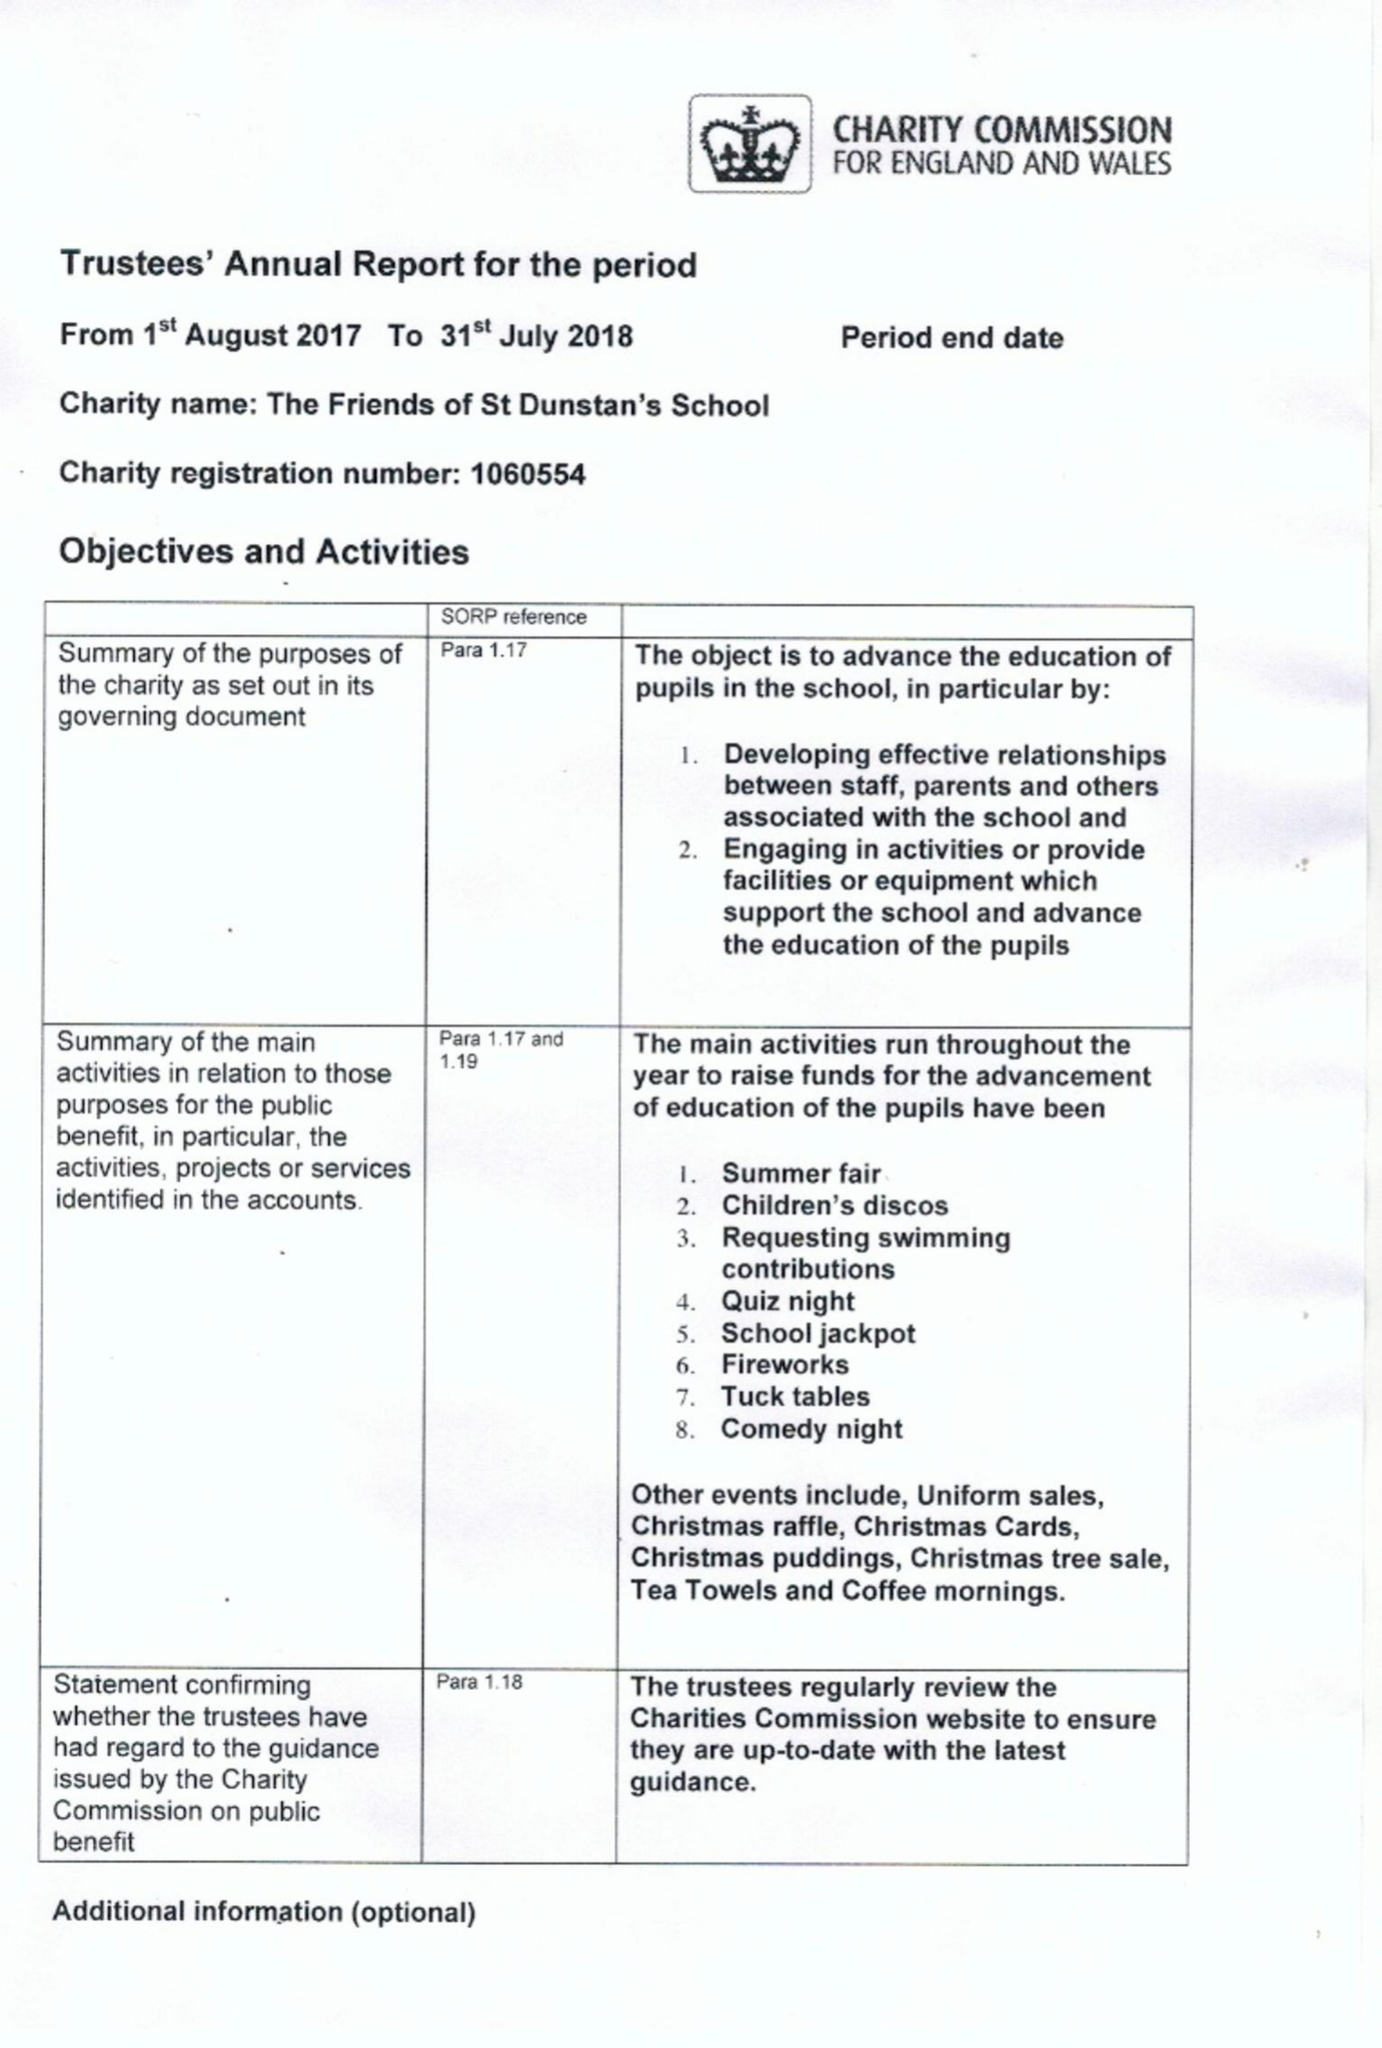What is the value for the charity_number?
Answer the question using a single word or phrase. 1060554 